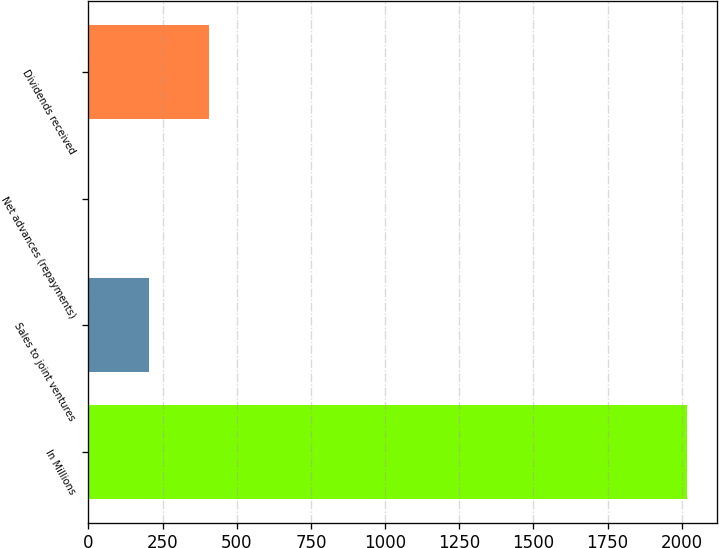Convert chart. <chart><loc_0><loc_0><loc_500><loc_500><bar_chart><fcel>In Millions<fcel>Sales to joint ventures<fcel>Net advances (repayments)<fcel>Dividends received<nl><fcel>2017<fcel>204.67<fcel>3.3<fcel>406.04<nl></chart> 